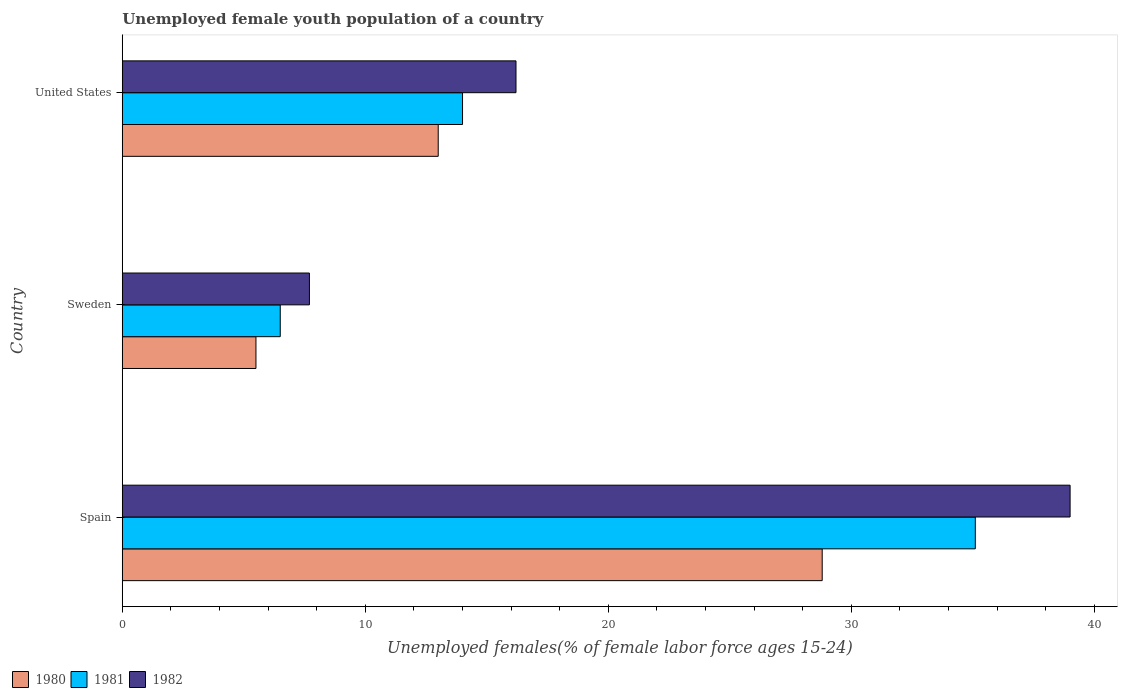How many different coloured bars are there?
Give a very brief answer. 3. How many groups of bars are there?
Provide a short and direct response. 3. Are the number of bars on each tick of the Y-axis equal?
Give a very brief answer. Yes. How many bars are there on the 2nd tick from the top?
Give a very brief answer. 3. In how many cases, is the number of bars for a given country not equal to the number of legend labels?
Your answer should be compact. 0. What is the percentage of unemployed female youth population in 1980 in Spain?
Provide a succinct answer. 28.8. Across all countries, what is the maximum percentage of unemployed female youth population in 1981?
Provide a succinct answer. 35.1. Across all countries, what is the minimum percentage of unemployed female youth population in 1982?
Ensure brevity in your answer.  7.7. In which country was the percentage of unemployed female youth population in 1981 minimum?
Your response must be concise. Sweden. What is the total percentage of unemployed female youth population in 1981 in the graph?
Provide a short and direct response. 55.6. What is the difference between the percentage of unemployed female youth population in 1981 in Sweden and that in United States?
Provide a short and direct response. -7.5. What is the difference between the percentage of unemployed female youth population in 1982 in Spain and the percentage of unemployed female youth population in 1980 in Sweden?
Offer a very short reply. 33.5. What is the average percentage of unemployed female youth population in 1982 per country?
Make the answer very short. 20.97. What is the difference between the percentage of unemployed female youth population in 1980 and percentage of unemployed female youth population in 1982 in Sweden?
Keep it short and to the point. -2.2. What is the ratio of the percentage of unemployed female youth population in 1980 in Spain to that in United States?
Give a very brief answer. 2.22. Is the difference between the percentage of unemployed female youth population in 1980 in Spain and United States greater than the difference between the percentage of unemployed female youth population in 1982 in Spain and United States?
Offer a terse response. No. What is the difference between the highest and the second highest percentage of unemployed female youth population in 1980?
Your answer should be very brief. 15.8. What is the difference between the highest and the lowest percentage of unemployed female youth population in 1981?
Offer a terse response. 28.6. How many bars are there?
Ensure brevity in your answer.  9. How are the legend labels stacked?
Make the answer very short. Horizontal. What is the title of the graph?
Make the answer very short. Unemployed female youth population of a country. What is the label or title of the X-axis?
Ensure brevity in your answer.  Unemployed females(% of female labor force ages 15-24). What is the Unemployed females(% of female labor force ages 15-24) of 1980 in Spain?
Make the answer very short. 28.8. What is the Unemployed females(% of female labor force ages 15-24) of 1981 in Spain?
Give a very brief answer. 35.1. What is the Unemployed females(% of female labor force ages 15-24) in 1980 in Sweden?
Your answer should be compact. 5.5. What is the Unemployed females(% of female labor force ages 15-24) of 1981 in Sweden?
Your answer should be very brief. 6.5. What is the Unemployed females(% of female labor force ages 15-24) of 1982 in Sweden?
Your answer should be very brief. 7.7. What is the Unemployed females(% of female labor force ages 15-24) in 1980 in United States?
Your answer should be very brief. 13. What is the Unemployed females(% of female labor force ages 15-24) of 1981 in United States?
Keep it short and to the point. 14. What is the Unemployed females(% of female labor force ages 15-24) in 1982 in United States?
Provide a succinct answer. 16.2. Across all countries, what is the maximum Unemployed females(% of female labor force ages 15-24) of 1980?
Ensure brevity in your answer.  28.8. Across all countries, what is the maximum Unemployed females(% of female labor force ages 15-24) in 1981?
Offer a terse response. 35.1. Across all countries, what is the minimum Unemployed females(% of female labor force ages 15-24) in 1981?
Provide a short and direct response. 6.5. Across all countries, what is the minimum Unemployed females(% of female labor force ages 15-24) in 1982?
Ensure brevity in your answer.  7.7. What is the total Unemployed females(% of female labor force ages 15-24) in 1980 in the graph?
Your response must be concise. 47.3. What is the total Unemployed females(% of female labor force ages 15-24) of 1981 in the graph?
Make the answer very short. 55.6. What is the total Unemployed females(% of female labor force ages 15-24) in 1982 in the graph?
Provide a short and direct response. 62.9. What is the difference between the Unemployed females(% of female labor force ages 15-24) in 1980 in Spain and that in Sweden?
Your answer should be compact. 23.3. What is the difference between the Unemployed females(% of female labor force ages 15-24) of 1981 in Spain and that in Sweden?
Keep it short and to the point. 28.6. What is the difference between the Unemployed females(% of female labor force ages 15-24) of 1982 in Spain and that in Sweden?
Keep it short and to the point. 31.3. What is the difference between the Unemployed females(% of female labor force ages 15-24) in 1981 in Spain and that in United States?
Keep it short and to the point. 21.1. What is the difference between the Unemployed females(% of female labor force ages 15-24) in 1982 in Spain and that in United States?
Your response must be concise. 22.8. What is the difference between the Unemployed females(% of female labor force ages 15-24) in 1980 in Sweden and that in United States?
Provide a succinct answer. -7.5. What is the difference between the Unemployed females(% of female labor force ages 15-24) in 1981 in Sweden and that in United States?
Provide a succinct answer. -7.5. What is the difference between the Unemployed females(% of female labor force ages 15-24) of 1982 in Sweden and that in United States?
Give a very brief answer. -8.5. What is the difference between the Unemployed females(% of female labor force ages 15-24) of 1980 in Spain and the Unemployed females(% of female labor force ages 15-24) of 1981 in Sweden?
Provide a short and direct response. 22.3. What is the difference between the Unemployed females(% of female labor force ages 15-24) of 1980 in Spain and the Unemployed females(% of female labor force ages 15-24) of 1982 in Sweden?
Keep it short and to the point. 21.1. What is the difference between the Unemployed females(% of female labor force ages 15-24) in 1981 in Spain and the Unemployed females(% of female labor force ages 15-24) in 1982 in Sweden?
Offer a very short reply. 27.4. What is the difference between the Unemployed females(% of female labor force ages 15-24) in 1980 in Sweden and the Unemployed females(% of female labor force ages 15-24) in 1981 in United States?
Offer a very short reply. -8.5. What is the average Unemployed females(% of female labor force ages 15-24) of 1980 per country?
Offer a very short reply. 15.77. What is the average Unemployed females(% of female labor force ages 15-24) of 1981 per country?
Provide a short and direct response. 18.53. What is the average Unemployed females(% of female labor force ages 15-24) in 1982 per country?
Provide a succinct answer. 20.97. What is the difference between the Unemployed females(% of female labor force ages 15-24) in 1980 and Unemployed females(% of female labor force ages 15-24) in 1981 in Spain?
Ensure brevity in your answer.  -6.3. What is the difference between the Unemployed females(% of female labor force ages 15-24) of 1980 and Unemployed females(% of female labor force ages 15-24) of 1982 in Spain?
Offer a terse response. -10.2. What is the difference between the Unemployed females(% of female labor force ages 15-24) in 1981 and Unemployed females(% of female labor force ages 15-24) in 1982 in Spain?
Offer a terse response. -3.9. What is the difference between the Unemployed females(% of female labor force ages 15-24) in 1980 and Unemployed females(% of female labor force ages 15-24) in 1981 in Sweden?
Provide a succinct answer. -1. What is the difference between the Unemployed females(% of female labor force ages 15-24) in 1980 and Unemployed females(% of female labor force ages 15-24) in 1982 in Sweden?
Provide a short and direct response. -2.2. What is the difference between the Unemployed females(% of female labor force ages 15-24) in 1980 and Unemployed females(% of female labor force ages 15-24) in 1982 in United States?
Ensure brevity in your answer.  -3.2. What is the ratio of the Unemployed females(% of female labor force ages 15-24) of 1980 in Spain to that in Sweden?
Provide a succinct answer. 5.24. What is the ratio of the Unemployed females(% of female labor force ages 15-24) of 1982 in Spain to that in Sweden?
Your answer should be compact. 5.06. What is the ratio of the Unemployed females(% of female labor force ages 15-24) in 1980 in Spain to that in United States?
Make the answer very short. 2.22. What is the ratio of the Unemployed females(% of female labor force ages 15-24) of 1981 in Spain to that in United States?
Give a very brief answer. 2.51. What is the ratio of the Unemployed females(% of female labor force ages 15-24) in 1982 in Spain to that in United States?
Ensure brevity in your answer.  2.41. What is the ratio of the Unemployed females(% of female labor force ages 15-24) in 1980 in Sweden to that in United States?
Your answer should be very brief. 0.42. What is the ratio of the Unemployed females(% of female labor force ages 15-24) of 1981 in Sweden to that in United States?
Your answer should be very brief. 0.46. What is the ratio of the Unemployed females(% of female labor force ages 15-24) of 1982 in Sweden to that in United States?
Your response must be concise. 0.48. What is the difference between the highest and the second highest Unemployed females(% of female labor force ages 15-24) in 1981?
Provide a succinct answer. 21.1. What is the difference between the highest and the second highest Unemployed females(% of female labor force ages 15-24) in 1982?
Make the answer very short. 22.8. What is the difference between the highest and the lowest Unemployed females(% of female labor force ages 15-24) in 1980?
Offer a terse response. 23.3. What is the difference between the highest and the lowest Unemployed females(% of female labor force ages 15-24) in 1981?
Make the answer very short. 28.6. What is the difference between the highest and the lowest Unemployed females(% of female labor force ages 15-24) of 1982?
Keep it short and to the point. 31.3. 